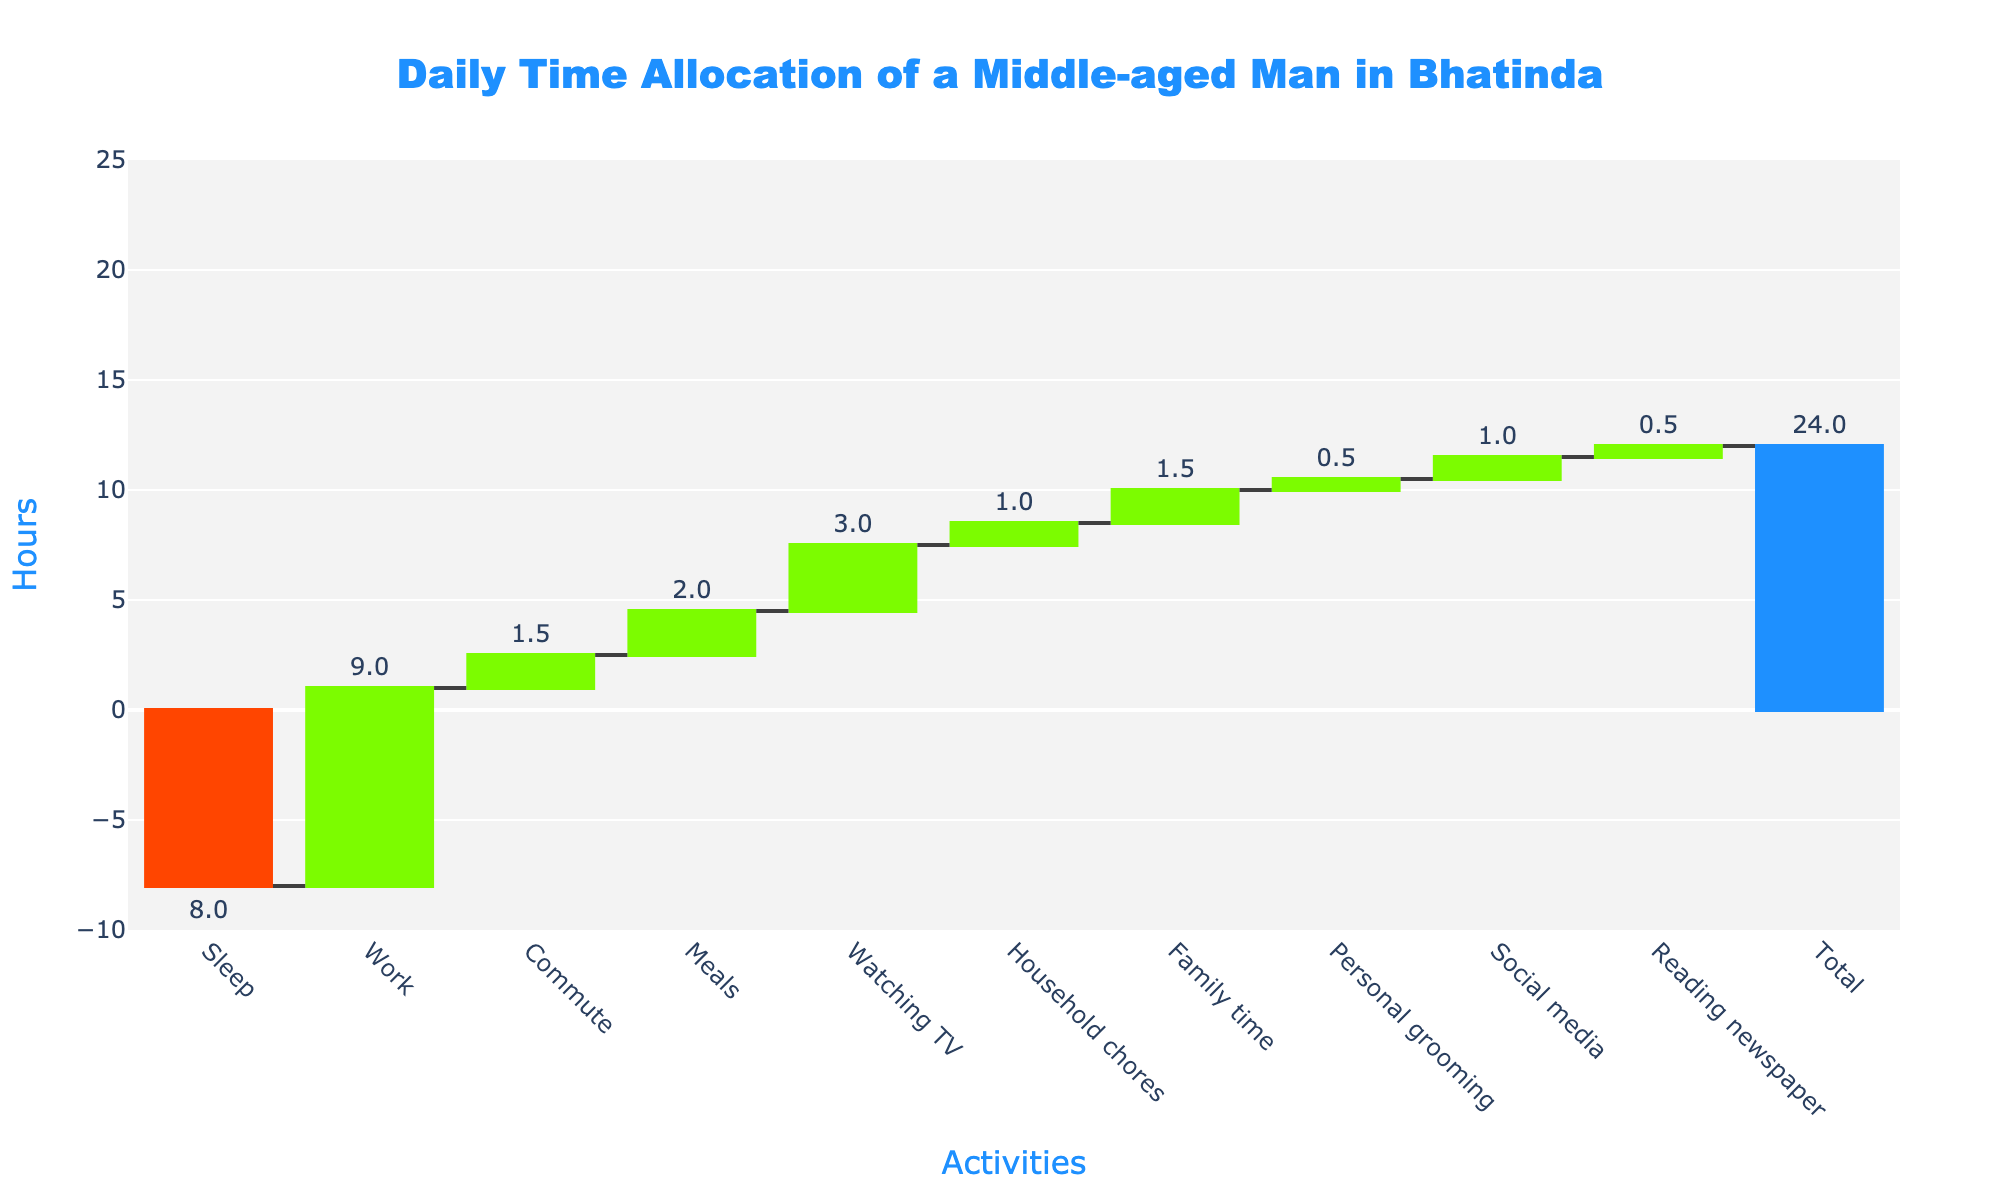What is the title of the chart? The title of the chart is prominently displayed at the top of the figure. It is used to give a summary or description of what the chart represents. The title is "Daily Time Allocation of a Middle-aged Man in Bhatinda".
Answer: Daily Time Allocation of a Middle-aged Man in Bhatinda How many activities are listed in the chart, excluding the total? The chart lists the daily activities on the x-axis, plus a total at the end. By counting the activities excluding the total, which is eleven.
Answer: 10 What are the total hours calculated for all activities combined? The total bar at the end of the chart represents the sum of all the individual activities' hours. This number directly answers the total hours calculated.
Answer: 24 How many hours are designated for sleeping? Identify the bar labeled "Sleep". The text position on the outside of this bar shows the number of hours allocated for sleep.
Answer: 8 hours What's the difference in hours between time spent on watching TV and social media? The hours for watching TV and social media are found by looking at their respective bars. Watching TV has 3 hours and social media has 1 hour. The difference is calculated by subtracting 1 from 3.
Answer: 2 hours What activity takes up the most time after work hours? Exclude the bar for "Work" and identify the highest bar among the remaining activities. Watching TV at 3 hours stands out as the next highest.
Answer: Watching TV How much time is spent on meals compared to personal grooming? Look at the bars for meals (2 hours) and for personal grooming (0.5 hours). The difference is calculated by subtracting the grooming time from meal time.
Answer: 1.5 hours What is the sum of the time spent on commute and family time? The hours for commute (1.5) and family time (1.5) are added together. 1.5 + 1.5 equals 3.
Answer: 3 hours Which activity is allocated the least amount of time? By comparing the heights of all bars for the activities, identify the shortest one. The bar for personal grooming is the shortest, indicating 0.5 hours.
Answer: Personal grooming How do the hours for household chores and social media compare? Identify the bars for household chores (1 hour) and social media (1 hour). Since they have the same height, they both take up an equal amount of time.
Answer: Equal, 1 hour each 